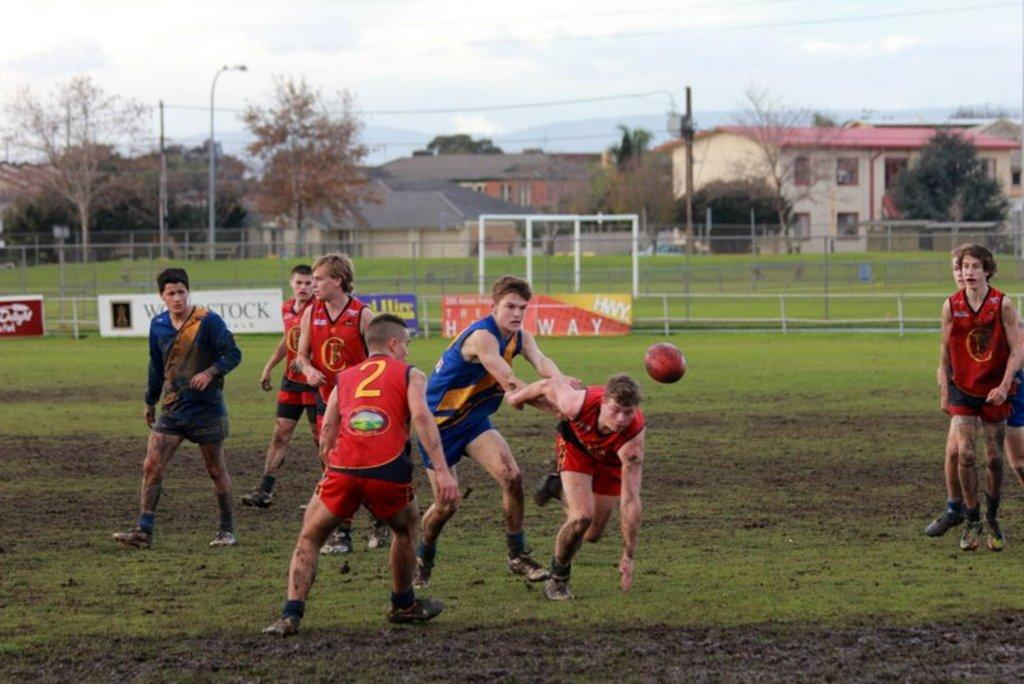<image>
Give a short and clear explanation of the subsequent image. two teams playing rugby, including red player 2 